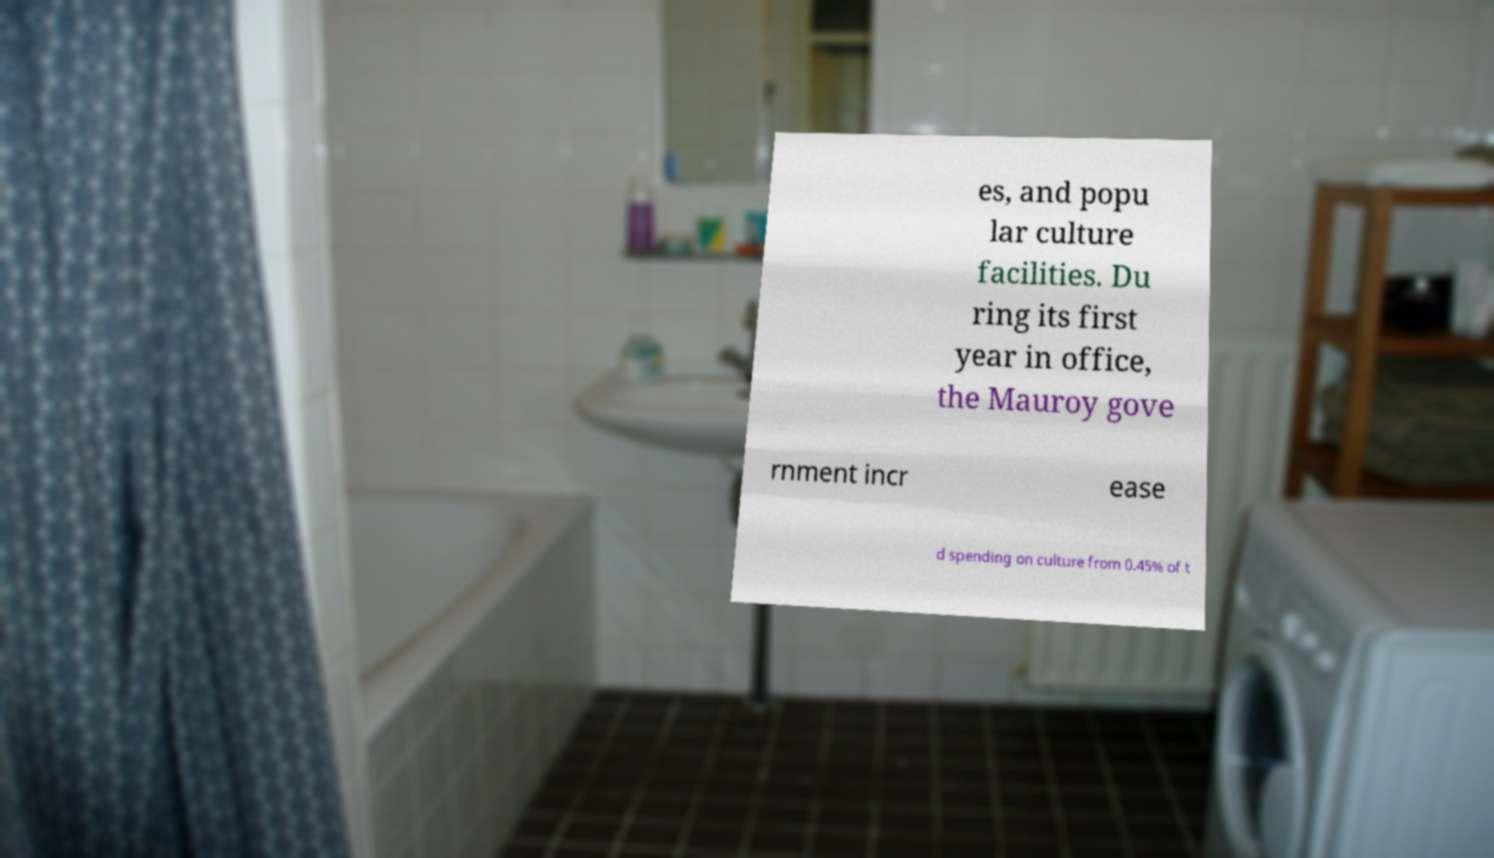Could you assist in decoding the text presented in this image and type it out clearly? es, and popu lar culture facilities. Du ring its first year in office, the Mauroy gove rnment incr ease d spending on culture from 0.45% of t 